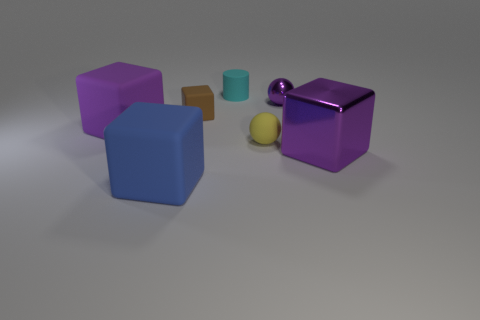Subtract all brown cubes. How many cubes are left? 3 Add 3 brown matte spheres. How many objects exist? 10 Subtract all purple spheres. How many spheres are left? 1 Subtract all blocks. How many objects are left? 3 Subtract 3 blocks. How many blocks are left? 1 Subtract all green cylinders. Subtract all gray spheres. How many cylinders are left? 1 Subtract all green spheres. How many yellow cubes are left? 0 Subtract all large shiny cubes. Subtract all tiny objects. How many objects are left? 2 Add 4 tiny metallic things. How many tiny metallic things are left? 5 Add 1 big green cylinders. How many big green cylinders exist? 1 